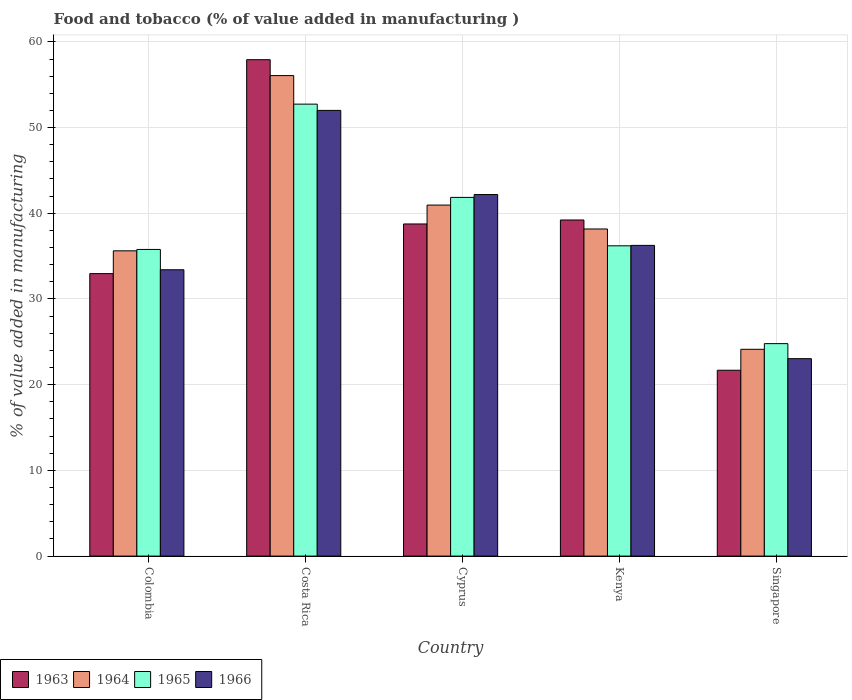How many groups of bars are there?
Provide a succinct answer. 5. How many bars are there on the 1st tick from the right?
Offer a terse response. 4. What is the label of the 2nd group of bars from the left?
Your answer should be very brief. Costa Rica. What is the value added in manufacturing food and tobacco in 1965 in Colombia?
Offer a terse response. 35.78. Across all countries, what is the maximum value added in manufacturing food and tobacco in 1966?
Ensure brevity in your answer.  52. Across all countries, what is the minimum value added in manufacturing food and tobacco in 1964?
Provide a short and direct response. 24.13. In which country was the value added in manufacturing food and tobacco in 1966 maximum?
Ensure brevity in your answer.  Costa Rica. In which country was the value added in manufacturing food and tobacco in 1966 minimum?
Offer a very short reply. Singapore. What is the total value added in manufacturing food and tobacco in 1966 in the graph?
Provide a short and direct response. 186.89. What is the difference between the value added in manufacturing food and tobacco in 1963 in Kenya and that in Singapore?
Provide a succinct answer. 17.53. What is the difference between the value added in manufacturing food and tobacco in 1965 in Singapore and the value added in manufacturing food and tobacco in 1966 in Kenya?
Ensure brevity in your answer.  -11.46. What is the average value added in manufacturing food and tobacco in 1963 per country?
Your answer should be compact. 38.11. What is the difference between the value added in manufacturing food and tobacco of/in 1965 and value added in manufacturing food and tobacco of/in 1966 in Singapore?
Your answer should be compact. 1.75. In how many countries, is the value added in manufacturing food and tobacco in 1964 greater than 48 %?
Your answer should be very brief. 1. What is the ratio of the value added in manufacturing food and tobacco in 1964 in Kenya to that in Singapore?
Your answer should be very brief. 1.58. Is the value added in manufacturing food and tobacco in 1964 in Kenya less than that in Singapore?
Make the answer very short. No. What is the difference between the highest and the second highest value added in manufacturing food and tobacco in 1964?
Provide a succinct answer. 15.11. What is the difference between the highest and the lowest value added in manufacturing food and tobacco in 1966?
Your answer should be very brief. 28.97. In how many countries, is the value added in manufacturing food and tobacco in 1964 greater than the average value added in manufacturing food and tobacco in 1964 taken over all countries?
Make the answer very short. 2. Is the sum of the value added in manufacturing food and tobacco in 1963 in Cyprus and Singapore greater than the maximum value added in manufacturing food and tobacco in 1964 across all countries?
Your answer should be compact. Yes. Is it the case that in every country, the sum of the value added in manufacturing food and tobacco in 1966 and value added in manufacturing food and tobacco in 1963 is greater than the sum of value added in manufacturing food and tobacco in 1965 and value added in manufacturing food and tobacco in 1964?
Offer a terse response. No. What does the 2nd bar from the right in Colombia represents?
Your answer should be very brief. 1965. How many bars are there?
Your response must be concise. 20. Are all the bars in the graph horizontal?
Your response must be concise. No. How many countries are there in the graph?
Keep it short and to the point. 5. What is the difference between two consecutive major ticks on the Y-axis?
Keep it short and to the point. 10. Does the graph contain any zero values?
Ensure brevity in your answer.  No. What is the title of the graph?
Ensure brevity in your answer.  Food and tobacco (% of value added in manufacturing ). Does "1998" appear as one of the legend labels in the graph?
Ensure brevity in your answer.  No. What is the label or title of the X-axis?
Provide a short and direct response. Country. What is the label or title of the Y-axis?
Offer a very short reply. % of value added in manufacturing. What is the % of value added in manufacturing in 1963 in Colombia?
Give a very brief answer. 32.96. What is the % of value added in manufacturing of 1964 in Colombia?
Ensure brevity in your answer.  35.62. What is the % of value added in manufacturing of 1965 in Colombia?
Your answer should be compact. 35.78. What is the % of value added in manufacturing in 1966 in Colombia?
Make the answer very short. 33.41. What is the % of value added in manufacturing in 1963 in Costa Rica?
Provide a succinct answer. 57.92. What is the % of value added in manufacturing of 1964 in Costa Rica?
Ensure brevity in your answer.  56.07. What is the % of value added in manufacturing in 1965 in Costa Rica?
Offer a terse response. 52.73. What is the % of value added in manufacturing of 1966 in Costa Rica?
Make the answer very short. 52. What is the % of value added in manufacturing of 1963 in Cyprus?
Make the answer very short. 38.75. What is the % of value added in manufacturing in 1964 in Cyprus?
Offer a very short reply. 40.96. What is the % of value added in manufacturing of 1965 in Cyprus?
Keep it short and to the point. 41.85. What is the % of value added in manufacturing of 1966 in Cyprus?
Offer a terse response. 42.19. What is the % of value added in manufacturing in 1963 in Kenya?
Ensure brevity in your answer.  39.22. What is the % of value added in manufacturing in 1964 in Kenya?
Give a very brief answer. 38.17. What is the % of value added in manufacturing of 1965 in Kenya?
Provide a short and direct response. 36.2. What is the % of value added in manufacturing in 1966 in Kenya?
Make the answer very short. 36.25. What is the % of value added in manufacturing of 1963 in Singapore?
Ensure brevity in your answer.  21.69. What is the % of value added in manufacturing of 1964 in Singapore?
Your response must be concise. 24.13. What is the % of value added in manufacturing in 1965 in Singapore?
Keep it short and to the point. 24.79. What is the % of value added in manufacturing of 1966 in Singapore?
Keep it short and to the point. 23.04. Across all countries, what is the maximum % of value added in manufacturing of 1963?
Give a very brief answer. 57.92. Across all countries, what is the maximum % of value added in manufacturing of 1964?
Offer a very short reply. 56.07. Across all countries, what is the maximum % of value added in manufacturing in 1965?
Keep it short and to the point. 52.73. Across all countries, what is the maximum % of value added in manufacturing of 1966?
Your response must be concise. 52. Across all countries, what is the minimum % of value added in manufacturing in 1963?
Your answer should be very brief. 21.69. Across all countries, what is the minimum % of value added in manufacturing in 1964?
Provide a succinct answer. 24.13. Across all countries, what is the minimum % of value added in manufacturing in 1965?
Offer a terse response. 24.79. Across all countries, what is the minimum % of value added in manufacturing of 1966?
Provide a succinct answer. 23.04. What is the total % of value added in manufacturing of 1963 in the graph?
Provide a succinct answer. 190.54. What is the total % of value added in manufacturing of 1964 in the graph?
Give a very brief answer. 194.94. What is the total % of value added in manufacturing in 1965 in the graph?
Your answer should be compact. 191.36. What is the total % of value added in manufacturing of 1966 in the graph?
Give a very brief answer. 186.89. What is the difference between the % of value added in manufacturing of 1963 in Colombia and that in Costa Rica?
Provide a short and direct response. -24.96. What is the difference between the % of value added in manufacturing of 1964 in Colombia and that in Costa Rica?
Offer a terse response. -20.45. What is the difference between the % of value added in manufacturing in 1965 in Colombia and that in Costa Rica?
Your response must be concise. -16.95. What is the difference between the % of value added in manufacturing in 1966 in Colombia and that in Costa Rica?
Provide a succinct answer. -18.59. What is the difference between the % of value added in manufacturing in 1963 in Colombia and that in Cyprus?
Offer a very short reply. -5.79. What is the difference between the % of value added in manufacturing in 1964 in Colombia and that in Cyprus?
Offer a terse response. -5.34. What is the difference between the % of value added in manufacturing in 1965 in Colombia and that in Cyprus?
Your response must be concise. -6.07. What is the difference between the % of value added in manufacturing of 1966 in Colombia and that in Cyprus?
Give a very brief answer. -8.78. What is the difference between the % of value added in manufacturing in 1963 in Colombia and that in Kenya?
Your answer should be very brief. -6.26. What is the difference between the % of value added in manufacturing of 1964 in Colombia and that in Kenya?
Ensure brevity in your answer.  -2.55. What is the difference between the % of value added in manufacturing of 1965 in Colombia and that in Kenya?
Keep it short and to the point. -0.42. What is the difference between the % of value added in manufacturing of 1966 in Colombia and that in Kenya?
Offer a terse response. -2.84. What is the difference between the % of value added in manufacturing in 1963 in Colombia and that in Singapore?
Provide a short and direct response. 11.27. What is the difference between the % of value added in manufacturing in 1964 in Colombia and that in Singapore?
Give a very brief answer. 11.49. What is the difference between the % of value added in manufacturing of 1965 in Colombia and that in Singapore?
Ensure brevity in your answer.  10.99. What is the difference between the % of value added in manufacturing of 1966 in Colombia and that in Singapore?
Provide a succinct answer. 10.37. What is the difference between the % of value added in manufacturing in 1963 in Costa Rica and that in Cyprus?
Your answer should be very brief. 19.17. What is the difference between the % of value added in manufacturing of 1964 in Costa Rica and that in Cyprus?
Your answer should be very brief. 15.11. What is the difference between the % of value added in manufacturing of 1965 in Costa Rica and that in Cyprus?
Offer a terse response. 10.88. What is the difference between the % of value added in manufacturing in 1966 in Costa Rica and that in Cyprus?
Your response must be concise. 9.82. What is the difference between the % of value added in manufacturing in 1963 in Costa Rica and that in Kenya?
Make the answer very short. 18.7. What is the difference between the % of value added in manufacturing in 1964 in Costa Rica and that in Kenya?
Your answer should be very brief. 17.9. What is the difference between the % of value added in manufacturing in 1965 in Costa Rica and that in Kenya?
Offer a very short reply. 16.53. What is the difference between the % of value added in manufacturing of 1966 in Costa Rica and that in Kenya?
Your answer should be compact. 15.75. What is the difference between the % of value added in manufacturing of 1963 in Costa Rica and that in Singapore?
Make the answer very short. 36.23. What is the difference between the % of value added in manufacturing of 1964 in Costa Rica and that in Singapore?
Provide a short and direct response. 31.94. What is the difference between the % of value added in manufacturing in 1965 in Costa Rica and that in Singapore?
Make the answer very short. 27.94. What is the difference between the % of value added in manufacturing of 1966 in Costa Rica and that in Singapore?
Provide a short and direct response. 28.97. What is the difference between the % of value added in manufacturing in 1963 in Cyprus and that in Kenya?
Give a very brief answer. -0.46. What is the difference between the % of value added in manufacturing of 1964 in Cyprus and that in Kenya?
Your answer should be very brief. 2.79. What is the difference between the % of value added in manufacturing in 1965 in Cyprus and that in Kenya?
Keep it short and to the point. 5.65. What is the difference between the % of value added in manufacturing in 1966 in Cyprus and that in Kenya?
Keep it short and to the point. 5.93. What is the difference between the % of value added in manufacturing of 1963 in Cyprus and that in Singapore?
Provide a short and direct response. 17.07. What is the difference between the % of value added in manufacturing of 1964 in Cyprus and that in Singapore?
Provide a short and direct response. 16.83. What is the difference between the % of value added in manufacturing of 1965 in Cyprus and that in Singapore?
Give a very brief answer. 17.06. What is the difference between the % of value added in manufacturing of 1966 in Cyprus and that in Singapore?
Your response must be concise. 19.15. What is the difference between the % of value added in manufacturing of 1963 in Kenya and that in Singapore?
Your answer should be very brief. 17.53. What is the difference between the % of value added in manufacturing of 1964 in Kenya and that in Singapore?
Your answer should be compact. 14.04. What is the difference between the % of value added in manufacturing of 1965 in Kenya and that in Singapore?
Provide a succinct answer. 11.41. What is the difference between the % of value added in manufacturing in 1966 in Kenya and that in Singapore?
Make the answer very short. 13.22. What is the difference between the % of value added in manufacturing of 1963 in Colombia and the % of value added in manufacturing of 1964 in Costa Rica?
Provide a short and direct response. -23.11. What is the difference between the % of value added in manufacturing of 1963 in Colombia and the % of value added in manufacturing of 1965 in Costa Rica?
Offer a terse response. -19.77. What is the difference between the % of value added in manufacturing in 1963 in Colombia and the % of value added in manufacturing in 1966 in Costa Rica?
Your response must be concise. -19.04. What is the difference between the % of value added in manufacturing of 1964 in Colombia and the % of value added in manufacturing of 1965 in Costa Rica?
Provide a succinct answer. -17.11. What is the difference between the % of value added in manufacturing of 1964 in Colombia and the % of value added in manufacturing of 1966 in Costa Rica?
Ensure brevity in your answer.  -16.38. What is the difference between the % of value added in manufacturing of 1965 in Colombia and the % of value added in manufacturing of 1966 in Costa Rica?
Keep it short and to the point. -16.22. What is the difference between the % of value added in manufacturing of 1963 in Colombia and the % of value added in manufacturing of 1964 in Cyprus?
Offer a very short reply. -8. What is the difference between the % of value added in manufacturing of 1963 in Colombia and the % of value added in manufacturing of 1965 in Cyprus?
Your answer should be compact. -8.89. What is the difference between the % of value added in manufacturing in 1963 in Colombia and the % of value added in manufacturing in 1966 in Cyprus?
Your answer should be very brief. -9.23. What is the difference between the % of value added in manufacturing in 1964 in Colombia and the % of value added in manufacturing in 1965 in Cyprus?
Keep it short and to the point. -6.23. What is the difference between the % of value added in manufacturing of 1964 in Colombia and the % of value added in manufacturing of 1966 in Cyprus?
Give a very brief answer. -6.57. What is the difference between the % of value added in manufacturing in 1965 in Colombia and the % of value added in manufacturing in 1966 in Cyprus?
Your response must be concise. -6.41. What is the difference between the % of value added in manufacturing of 1963 in Colombia and the % of value added in manufacturing of 1964 in Kenya?
Your answer should be compact. -5.21. What is the difference between the % of value added in manufacturing of 1963 in Colombia and the % of value added in manufacturing of 1965 in Kenya?
Your response must be concise. -3.24. What is the difference between the % of value added in manufacturing of 1963 in Colombia and the % of value added in manufacturing of 1966 in Kenya?
Keep it short and to the point. -3.29. What is the difference between the % of value added in manufacturing of 1964 in Colombia and the % of value added in manufacturing of 1965 in Kenya?
Your answer should be very brief. -0.58. What is the difference between the % of value added in manufacturing in 1964 in Colombia and the % of value added in manufacturing in 1966 in Kenya?
Offer a terse response. -0.63. What is the difference between the % of value added in manufacturing in 1965 in Colombia and the % of value added in manufacturing in 1966 in Kenya?
Your response must be concise. -0.47. What is the difference between the % of value added in manufacturing in 1963 in Colombia and the % of value added in manufacturing in 1964 in Singapore?
Provide a short and direct response. 8.83. What is the difference between the % of value added in manufacturing of 1963 in Colombia and the % of value added in manufacturing of 1965 in Singapore?
Your answer should be very brief. 8.17. What is the difference between the % of value added in manufacturing in 1963 in Colombia and the % of value added in manufacturing in 1966 in Singapore?
Provide a short and direct response. 9.92. What is the difference between the % of value added in manufacturing in 1964 in Colombia and the % of value added in manufacturing in 1965 in Singapore?
Offer a very short reply. 10.83. What is the difference between the % of value added in manufacturing of 1964 in Colombia and the % of value added in manufacturing of 1966 in Singapore?
Provide a succinct answer. 12.58. What is the difference between the % of value added in manufacturing in 1965 in Colombia and the % of value added in manufacturing in 1966 in Singapore?
Ensure brevity in your answer.  12.74. What is the difference between the % of value added in manufacturing in 1963 in Costa Rica and the % of value added in manufacturing in 1964 in Cyprus?
Keep it short and to the point. 16.96. What is the difference between the % of value added in manufacturing in 1963 in Costa Rica and the % of value added in manufacturing in 1965 in Cyprus?
Give a very brief answer. 16.07. What is the difference between the % of value added in manufacturing of 1963 in Costa Rica and the % of value added in manufacturing of 1966 in Cyprus?
Offer a terse response. 15.73. What is the difference between the % of value added in manufacturing of 1964 in Costa Rica and the % of value added in manufacturing of 1965 in Cyprus?
Your response must be concise. 14.21. What is the difference between the % of value added in manufacturing of 1964 in Costa Rica and the % of value added in manufacturing of 1966 in Cyprus?
Ensure brevity in your answer.  13.88. What is the difference between the % of value added in manufacturing of 1965 in Costa Rica and the % of value added in manufacturing of 1966 in Cyprus?
Give a very brief answer. 10.55. What is the difference between the % of value added in manufacturing in 1963 in Costa Rica and the % of value added in manufacturing in 1964 in Kenya?
Keep it short and to the point. 19.75. What is the difference between the % of value added in manufacturing in 1963 in Costa Rica and the % of value added in manufacturing in 1965 in Kenya?
Offer a very short reply. 21.72. What is the difference between the % of value added in manufacturing of 1963 in Costa Rica and the % of value added in manufacturing of 1966 in Kenya?
Ensure brevity in your answer.  21.67. What is the difference between the % of value added in manufacturing of 1964 in Costa Rica and the % of value added in manufacturing of 1965 in Kenya?
Make the answer very short. 19.86. What is the difference between the % of value added in manufacturing in 1964 in Costa Rica and the % of value added in manufacturing in 1966 in Kenya?
Offer a very short reply. 19.81. What is the difference between the % of value added in manufacturing of 1965 in Costa Rica and the % of value added in manufacturing of 1966 in Kenya?
Your response must be concise. 16.48. What is the difference between the % of value added in manufacturing of 1963 in Costa Rica and the % of value added in manufacturing of 1964 in Singapore?
Ensure brevity in your answer.  33.79. What is the difference between the % of value added in manufacturing in 1963 in Costa Rica and the % of value added in manufacturing in 1965 in Singapore?
Give a very brief answer. 33.13. What is the difference between the % of value added in manufacturing in 1963 in Costa Rica and the % of value added in manufacturing in 1966 in Singapore?
Give a very brief answer. 34.88. What is the difference between the % of value added in manufacturing in 1964 in Costa Rica and the % of value added in manufacturing in 1965 in Singapore?
Your answer should be compact. 31.28. What is the difference between the % of value added in manufacturing in 1964 in Costa Rica and the % of value added in manufacturing in 1966 in Singapore?
Provide a short and direct response. 33.03. What is the difference between the % of value added in manufacturing of 1965 in Costa Rica and the % of value added in manufacturing of 1966 in Singapore?
Your answer should be very brief. 29.7. What is the difference between the % of value added in manufacturing in 1963 in Cyprus and the % of value added in manufacturing in 1964 in Kenya?
Provide a short and direct response. 0.59. What is the difference between the % of value added in manufacturing of 1963 in Cyprus and the % of value added in manufacturing of 1965 in Kenya?
Your answer should be very brief. 2.55. What is the difference between the % of value added in manufacturing in 1963 in Cyprus and the % of value added in manufacturing in 1966 in Kenya?
Keep it short and to the point. 2.5. What is the difference between the % of value added in manufacturing in 1964 in Cyprus and the % of value added in manufacturing in 1965 in Kenya?
Your response must be concise. 4.75. What is the difference between the % of value added in manufacturing in 1964 in Cyprus and the % of value added in manufacturing in 1966 in Kenya?
Ensure brevity in your answer.  4.7. What is the difference between the % of value added in manufacturing in 1965 in Cyprus and the % of value added in manufacturing in 1966 in Kenya?
Provide a short and direct response. 5.6. What is the difference between the % of value added in manufacturing of 1963 in Cyprus and the % of value added in manufacturing of 1964 in Singapore?
Ensure brevity in your answer.  14.63. What is the difference between the % of value added in manufacturing in 1963 in Cyprus and the % of value added in manufacturing in 1965 in Singapore?
Ensure brevity in your answer.  13.96. What is the difference between the % of value added in manufacturing of 1963 in Cyprus and the % of value added in manufacturing of 1966 in Singapore?
Keep it short and to the point. 15.72. What is the difference between the % of value added in manufacturing in 1964 in Cyprus and the % of value added in manufacturing in 1965 in Singapore?
Your answer should be very brief. 16.17. What is the difference between the % of value added in manufacturing in 1964 in Cyprus and the % of value added in manufacturing in 1966 in Singapore?
Your answer should be compact. 17.92. What is the difference between the % of value added in manufacturing in 1965 in Cyprus and the % of value added in manufacturing in 1966 in Singapore?
Provide a short and direct response. 18.82. What is the difference between the % of value added in manufacturing of 1963 in Kenya and the % of value added in manufacturing of 1964 in Singapore?
Offer a terse response. 15.09. What is the difference between the % of value added in manufacturing in 1963 in Kenya and the % of value added in manufacturing in 1965 in Singapore?
Give a very brief answer. 14.43. What is the difference between the % of value added in manufacturing in 1963 in Kenya and the % of value added in manufacturing in 1966 in Singapore?
Give a very brief answer. 16.18. What is the difference between the % of value added in manufacturing of 1964 in Kenya and the % of value added in manufacturing of 1965 in Singapore?
Your answer should be very brief. 13.38. What is the difference between the % of value added in manufacturing in 1964 in Kenya and the % of value added in manufacturing in 1966 in Singapore?
Offer a terse response. 15.13. What is the difference between the % of value added in manufacturing of 1965 in Kenya and the % of value added in manufacturing of 1966 in Singapore?
Ensure brevity in your answer.  13.17. What is the average % of value added in manufacturing of 1963 per country?
Give a very brief answer. 38.11. What is the average % of value added in manufacturing in 1964 per country?
Offer a terse response. 38.99. What is the average % of value added in manufacturing of 1965 per country?
Provide a short and direct response. 38.27. What is the average % of value added in manufacturing in 1966 per country?
Your answer should be compact. 37.38. What is the difference between the % of value added in manufacturing of 1963 and % of value added in manufacturing of 1964 in Colombia?
Give a very brief answer. -2.66. What is the difference between the % of value added in manufacturing of 1963 and % of value added in manufacturing of 1965 in Colombia?
Offer a terse response. -2.82. What is the difference between the % of value added in manufacturing of 1963 and % of value added in manufacturing of 1966 in Colombia?
Provide a succinct answer. -0.45. What is the difference between the % of value added in manufacturing of 1964 and % of value added in manufacturing of 1965 in Colombia?
Your answer should be compact. -0.16. What is the difference between the % of value added in manufacturing of 1964 and % of value added in manufacturing of 1966 in Colombia?
Give a very brief answer. 2.21. What is the difference between the % of value added in manufacturing in 1965 and % of value added in manufacturing in 1966 in Colombia?
Give a very brief answer. 2.37. What is the difference between the % of value added in manufacturing in 1963 and % of value added in manufacturing in 1964 in Costa Rica?
Your answer should be compact. 1.85. What is the difference between the % of value added in manufacturing in 1963 and % of value added in manufacturing in 1965 in Costa Rica?
Offer a very short reply. 5.19. What is the difference between the % of value added in manufacturing in 1963 and % of value added in manufacturing in 1966 in Costa Rica?
Your answer should be compact. 5.92. What is the difference between the % of value added in manufacturing in 1964 and % of value added in manufacturing in 1965 in Costa Rica?
Provide a short and direct response. 3.33. What is the difference between the % of value added in manufacturing in 1964 and % of value added in manufacturing in 1966 in Costa Rica?
Your answer should be very brief. 4.06. What is the difference between the % of value added in manufacturing in 1965 and % of value added in manufacturing in 1966 in Costa Rica?
Your answer should be very brief. 0.73. What is the difference between the % of value added in manufacturing in 1963 and % of value added in manufacturing in 1964 in Cyprus?
Ensure brevity in your answer.  -2.2. What is the difference between the % of value added in manufacturing in 1963 and % of value added in manufacturing in 1965 in Cyprus?
Keep it short and to the point. -3.1. What is the difference between the % of value added in manufacturing of 1963 and % of value added in manufacturing of 1966 in Cyprus?
Make the answer very short. -3.43. What is the difference between the % of value added in manufacturing in 1964 and % of value added in manufacturing in 1965 in Cyprus?
Ensure brevity in your answer.  -0.9. What is the difference between the % of value added in manufacturing in 1964 and % of value added in manufacturing in 1966 in Cyprus?
Provide a succinct answer. -1.23. What is the difference between the % of value added in manufacturing of 1965 and % of value added in manufacturing of 1966 in Cyprus?
Give a very brief answer. -0.33. What is the difference between the % of value added in manufacturing in 1963 and % of value added in manufacturing in 1964 in Kenya?
Offer a terse response. 1.05. What is the difference between the % of value added in manufacturing of 1963 and % of value added in manufacturing of 1965 in Kenya?
Keep it short and to the point. 3.01. What is the difference between the % of value added in manufacturing of 1963 and % of value added in manufacturing of 1966 in Kenya?
Your answer should be compact. 2.96. What is the difference between the % of value added in manufacturing of 1964 and % of value added in manufacturing of 1965 in Kenya?
Give a very brief answer. 1.96. What is the difference between the % of value added in manufacturing in 1964 and % of value added in manufacturing in 1966 in Kenya?
Offer a very short reply. 1.91. What is the difference between the % of value added in manufacturing of 1963 and % of value added in manufacturing of 1964 in Singapore?
Your response must be concise. -2.44. What is the difference between the % of value added in manufacturing of 1963 and % of value added in manufacturing of 1965 in Singapore?
Make the answer very short. -3.1. What is the difference between the % of value added in manufacturing of 1963 and % of value added in manufacturing of 1966 in Singapore?
Ensure brevity in your answer.  -1.35. What is the difference between the % of value added in manufacturing of 1964 and % of value added in manufacturing of 1965 in Singapore?
Provide a succinct answer. -0.66. What is the difference between the % of value added in manufacturing of 1964 and % of value added in manufacturing of 1966 in Singapore?
Your answer should be very brief. 1.09. What is the difference between the % of value added in manufacturing of 1965 and % of value added in manufacturing of 1966 in Singapore?
Offer a very short reply. 1.75. What is the ratio of the % of value added in manufacturing of 1963 in Colombia to that in Costa Rica?
Offer a very short reply. 0.57. What is the ratio of the % of value added in manufacturing of 1964 in Colombia to that in Costa Rica?
Make the answer very short. 0.64. What is the ratio of the % of value added in manufacturing in 1965 in Colombia to that in Costa Rica?
Your answer should be compact. 0.68. What is the ratio of the % of value added in manufacturing in 1966 in Colombia to that in Costa Rica?
Ensure brevity in your answer.  0.64. What is the ratio of the % of value added in manufacturing in 1963 in Colombia to that in Cyprus?
Your response must be concise. 0.85. What is the ratio of the % of value added in manufacturing of 1964 in Colombia to that in Cyprus?
Offer a terse response. 0.87. What is the ratio of the % of value added in manufacturing in 1965 in Colombia to that in Cyprus?
Offer a terse response. 0.85. What is the ratio of the % of value added in manufacturing in 1966 in Colombia to that in Cyprus?
Your answer should be very brief. 0.79. What is the ratio of the % of value added in manufacturing in 1963 in Colombia to that in Kenya?
Your response must be concise. 0.84. What is the ratio of the % of value added in manufacturing of 1964 in Colombia to that in Kenya?
Provide a succinct answer. 0.93. What is the ratio of the % of value added in manufacturing of 1965 in Colombia to that in Kenya?
Your answer should be compact. 0.99. What is the ratio of the % of value added in manufacturing in 1966 in Colombia to that in Kenya?
Keep it short and to the point. 0.92. What is the ratio of the % of value added in manufacturing in 1963 in Colombia to that in Singapore?
Make the answer very short. 1.52. What is the ratio of the % of value added in manufacturing of 1964 in Colombia to that in Singapore?
Provide a short and direct response. 1.48. What is the ratio of the % of value added in manufacturing of 1965 in Colombia to that in Singapore?
Provide a short and direct response. 1.44. What is the ratio of the % of value added in manufacturing of 1966 in Colombia to that in Singapore?
Offer a very short reply. 1.45. What is the ratio of the % of value added in manufacturing of 1963 in Costa Rica to that in Cyprus?
Keep it short and to the point. 1.49. What is the ratio of the % of value added in manufacturing of 1964 in Costa Rica to that in Cyprus?
Your response must be concise. 1.37. What is the ratio of the % of value added in manufacturing of 1965 in Costa Rica to that in Cyprus?
Offer a very short reply. 1.26. What is the ratio of the % of value added in manufacturing in 1966 in Costa Rica to that in Cyprus?
Offer a very short reply. 1.23. What is the ratio of the % of value added in manufacturing in 1963 in Costa Rica to that in Kenya?
Provide a short and direct response. 1.48. What is the ratio of the % of value added in manufacturing in 1964 in Costa Rica to that in Kenya?
Offer a very short reply. 1.47. What is the ratio of the % of value added in manufacturing of 1965 in Costa Rica to that in Kenya?
Ensure brevity in your answer.  1.46. What is the ratio of the % of value added in manufacturing in 1966 in Costa Rica to that in Kenya?
Your response must be concise. 1.43. What is the ratio of the % of value added in manufacturing of 1963 in Costa Rica to that in Singapore?
Keep it short and to the point. 2.67. What is the ratio of the % of value added in manufacturing of 1964 in Costa Rica to that in Singapore?
Your response must be concise. 2.32. What is the ratio of the % of value added in manufacturing of 1965 in Costa Rica to that in Singapore?
Offer a terse response. 2.13. What is the ratio of the % of value added in manufacturing of 1966 in Costa Rica to that in Singapore?
Give a very brief answer. 2.26. What is the ratio of the % of value added in manufacturing of 1963 in Cyprus to that in Kenya?
Your answer should be very brief. 0.99. What is the ratio of the % of value added in manufacturing of 1964 in Cyprus to that in Kenya?
Your response must be concise. 1.07. What is the ratio of the % of value added in manufacturing in 1965 in Cyprus to that in Kenya?
Provide a short and direct response. 1.16. What is the ratio of the % of value added in manufacturing of 1966 in Cyprus to that in Kenya?
Keep it short and to the point. 1.16. What is the ratio of the % of value added in manufacturing in 1963 in Cyprus to that in Singapore?
Provide a short and direct response. 1.79. What is the ratio of the % of value added in manufacturing of 1964 in Cyprus to that in Singapore?
Keep it short and to the point. 1.7. What is the ratio of the % of value added in manufacturing in 1965 in Cyprus to that in Singapore?
Keep it short and to the point. 1.69. What is the ratio of the % of value added in manufacturing in 1966 in Cyprus to that in Singapore?
Your answer should be very brief. 1.83. What is the ratio of the % of value added in manufacturing of 1963 in Kenya to that in Singapore?
Your response must be concise. 1.81. What is the ratio of the % of value added in manufacturing in 1964 in Kenya to that in Singapore?
Offer a terse response. 1.58. What is the ratio of the % of value added in manufacturing of 1965 in Kenya to that in Singapore?
Offer a terse response. 1.46. What is the ratio of the % of value added in manufacturing of 1966 in Kenya to that in Singapore?
Your answer should be compact. 1.57. What is the difference between the highest and the second highest % of value added in manufacturing of 1963?
Give a very brief answer. 18.7. What is the difference between the highest and the second highest % of value added in manufacturing in 1964?
Offer a very short reply. 15.11. What is the difference between the highest and the second highest % of value added in manufacturing of 1965?
Keep it short and to the point. 10.88. What is the difference between the highest and the second highest % of value added in manufacturing of 1966?
Provide a short and direct response. 9.82. What is the difference between the highest and the lowest % of value added in manufacturing in 1963?
Ensure brevity in your answer.  36.23. What is the difference between the highest and the lowest % of value added in manufacturing in 1964?
Your answer should be compact. 31.94. What is the difference between the highest and the lowest % of value added in manufacturing of 1965?
Make the answer very short. 27.94. What is the difference between the highest and the lowest % of value added in manufacturing of 1966?
Offer a terse response. 28.97. 